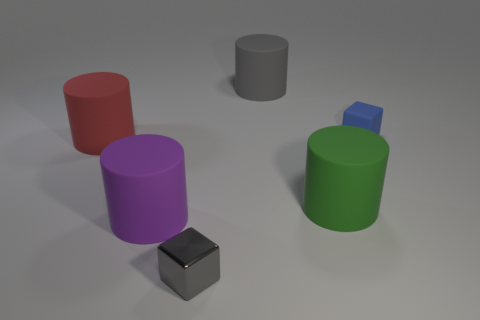Subtract all green cylinders. Subtract all yellow spheres. How many cylinders are left? 3 Add 4 big green cylinders. How many objects exist? 10 Subtract all cubes. How many objects are left? 4 Subtract 0 purple spheres. How many objects are left? 6 Subtract all metal things. Subtract all small blue objects. How many objects are left? 4 Add 5 large red objects. How many large red objects are left? 6 Add 1 cylinders. How many cylinders exist? 5 